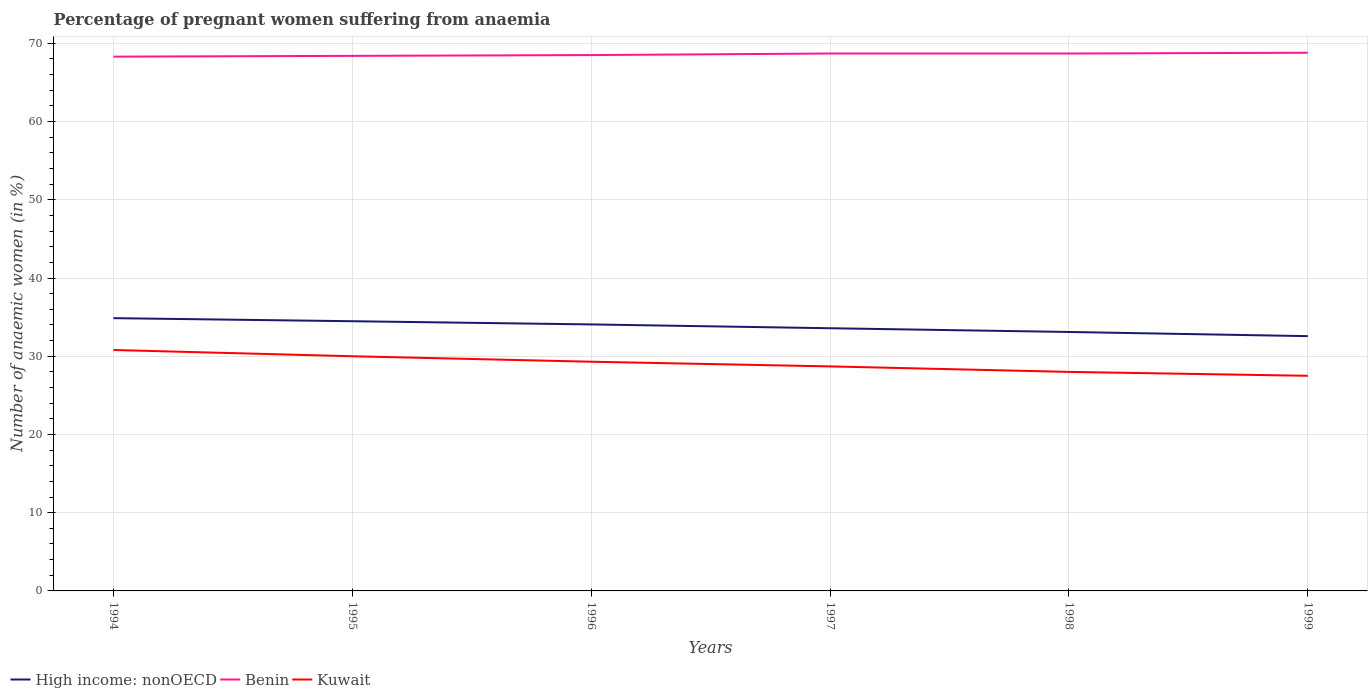How many different coloured lines are there?
Offer a very short reply. 3. What is the total number of anaemic women in Benin in the graph?
Make the answer very short. -0.3. What is the difference between the highest and the second highest number of anaemic women in Benin?
Make the answer very short. 0.5. Is the number of anaemic women in High income: nonOECD strictly greater than the number of anaemic women in Benin over the years?
Give a very brief answer. Yes. How many lines are there?
Make the answer very short. 3. How many years are there in the graph?
Keep it short and to the point. 6. Does the graph contain any zero values?
Offer a terse response. No. Does the graph contain grids?
Ensure brevity in your answer.  Yes. How many legend labels are there?
Provide a succinct answer. 3. How are the legend labels stacked?
Your response must be concise. Horizontal. What is the title of the graph?
Keep it short and to the point. Percentage of pregnant women suffering from anaemia. What is the label or title of the X-axis?
Your answer should be compact. Years. What is the label or title of the Y-axis?
Offer a terse response. Number of anaemic women (in %). What is the Number of anaemic women (in %) of High income: nonOECD in 1994?
Your response must be concise. 34.87. What is the Number of anaemic women (in %) in Benin in 1994?
Keep it short and to the point. 68.3. What is the Number of anaemic women (in %) in Kuwait in 1994?
Provide a succinct answer. 30.8. What is the Number of anaemic women (in %) in High income: nonOECD in 1995?
Keep it short and to the point. 34.48. What is the Number of anaemic women (in %) of Benin in 1995?
Provide a short and direct response. 68.4. What is the Number of anaemic women (in %) in Kuwait in 1995?
Your response must be concise. 30. What is the Number of anaemic women (in %) of High income: nonOECD in 1996?
Your response must be concise. 34.07. What is the Number of anaemic women (in %) of Benin in 1996?
Your answer should be very brief. 68.5. What is the Number of anaemic women (in %) of Kuwait in 1996?
Your response must be concise. 29.3. What is the Number of anaemic women (in %) in High income: nonOECD in 1997?
Give a very brief answer. 33.58. What is the Number of anaemic women (in %) of Benin in 1997?
Give a very brief answer. 68.7. What is the Number of anaemic women (in %) of Kuwait in 1997?
Offer a very short reply. 28.7. What is the Number of anaemic women (in %) in High income: nonOECD in 1998?
Offer a terse response. 33.1. What is the Number of anaemic women (in %) of Benin in 1998?
Provide a succinct answer. 68.7. What is the Number of anaemic women (in %) in High income: nonOECD in 1999?
Offer a very short reply. 32.57. What is the Number of anaemic women (in %) of Benin in 1999?
Your answer should be compact. 68.8. Across all years, what is the maximum Number of anaemic women (in %) of High income: nonOECD?
Offer a very short reply. 34.87. Across all years, what is the maximum Number of anaemic women (in %) of Benin?
Make the answer very short. 68.8. Across all years, what is the maximum Number of anaemic women (in %) in Kuwait?
Your answer should be very brief. 30.8. Across all years, what is the minimum Number of anaemic women (in %) in High income: nonOECD?
Ensure brevity in your answer.  32.57. Across all years, what is the minimum Number of anaemic women (in %) in Benin?
Your response must be concise. 68.3. Across all years, what is the minimum Number of anaemic women (in %) in Kuwait?
Give a very brief answer. 27.5. What is the total Number of anaemic women (in %) in High income: nonOECD in the graph?
Provide a short and direct response. 202.67. What is the total Number of anaemic women (in %) of Benin in the graph?
Offer a very short reply. 411.4. What is the total Number of anaemic women (in %) of Kuwait in the graph?
Offer a terse response. 174.3. What is the difference between the Number of anaemic women (in %) in High income: nonOECD in 1994 and that in 1995?
Make the answer very short. 0.39. What is the difference between the Number of anaemic women (in %) in Kuwait in 1994 and that in 1995?
Keep it short and to the point. 0.8. What is the difference between the Number of anaemic women (in %) in High income: nonOECD in 1994 and that in 1996?
Keep it short and to the point. 0.8. What is the difference between the Number of anaemic women (in %) of Benin in 1994 and that in 1996?
Your answer should be very brief. -0.2. What is the difference between the Number of anaemic women (in %) in High income: nonOECD in 1994 and that in 1997?
Offer a terse response. 1.29. What is the difference between the Number of anaemic women (in %) in Kuwait in 1994 and that in 1997?
Your response must be concise. 2.1. What is the difference between the Number of anaemic women (in %) of High income: nonOECD in 1994 and that in 1998?
Give a very brief answer. 1.76. What is the difference between the Number of anaemic women (in %) in Benin in 1994 and that in 1998?
Make the answer very short. -0.4. What is the difference between the Number of anaemic women (in %) of Kuwait in 1994 and that in 1998?
Offer a terse response. 2.8. What is the difference between the Number of anaemic women (in %) of High income: nonOECD in 1994 and that in 1999?
Offer a very short reply. 2.3. What is the difference between the Number of anaemic women (in %) in High income: nonOECD in 1995 and that in 1996?
Ensure brevity in your answer.  0.41. What is the difference between the Number of anaemic women (in %) in Kuwait in 1995 and that in 1996?
Keep it short and to the point. 0.7. What is the difference between the Number of anaemic women (in %) in High income: nonOECD in 1995 and that in 1997?
Ensure brevity in your answer.  0.9. What is the difference between the Number of anaemic women (in %) of Benin in 1995 and that in 1997?
Your response must be concise. -0.3. What is the difference between the Number of anaemic women (in %) of Kuwait in 1995 and that in 1997?
Give a very brief answer. 1.3. What is the difference between the Number of anaemic women (in %) of High income: nonOECD in 1995 and that in 1998?
Offer a terse response. 1.37. What is the difference between the Number of anaemic women (in %) in Kuwait in 1995 and that in 1998?
Make the answer very short. 2. What is the difference between the Number of anaemic women (in %) in High income: nonOECD in 1995 and that in 1999?
Offer a terse response. 1.91. What is the difference between the Number of anaemic women (in %) of Benin in 1995 and that in 1999?
Make the answer very short. -0.4. What is the difference between the Number of anaemic women (in %) in High income: nonOECD in 1996 and that in 1997?
Provide a short and direct response. 0.49. What is the difference between the Number of anaemic women (in %) in Benin in 1996 and that in 1997?
Your response must be concise. -0.2. What is the difference between the Number of anaemic women (in %) in High income: nonOECD in 1996 and that in 1998?
Provide a succinct answer. 0.96. What is the difference between the Number of anaemic women (in %) of High income: nonOECD in 1996 and that in 1999?
Your answer should be very brief. 1.5. What is the difference between the Number of anaemic women (in %) of Kuwait in 1996 and that in 1999?
Offer a very short reply. 1.8. What is the difference between the Number of anaemic women (in %) in High income: nonOECD in 1997 and that in 1998?
Offer a terse response. 0.48. What is the difference between the Number of anaemic women (in %) in Kuwait in 1997 and that in 1998?
Provide a short and direct response. 0.7. What is the difference between the Number of anaemic women (in %) of High income: nonOECD in 1997 and that in 1999?
Give a very brief answer. 1.01. What is the difference between the Number of anaemic women (in %) in Benin in 1997 and that in 1999?
Make the answer very short. -0.1. What is the difference between the Number of anaemic women (in %) of Kuwait in 1997 and that in 1999?
Your answer should be compact. 1.2. What is the difference between the Number of anaemic women (in %) of High income: nonOECD in 1998 and that in 1999?
Keep it short and to the point. 0.53. What is the difference between the Number of anaemic women (in %) of Benin in 1998 and that in 1999?
Offer a terse response. -0.1. What is the difference between the Number of anaemic women (in %) of Kuwait in 1998 and that in 1999?
Keep it short and to the point. 0.5. What is the difference between the Number of anaemic women (in %) of High income: nonOECD in 1994 and the Number of anaemic women (in %) of Benin in 1995?
Keep it short and to the point. -33.53. What is the difference between the Number of anaemic women (in %) of High income: nonOECD in 1994 and the Number of anaemic women (in %) of Kuwait in 1995?
Give a very brief answer. 4.87. What is the difference between the Number of anaemic women (in %) in Benin in 1994 and the Number of anaemic women (in %) in Kuwait in 1995?
Offer a terse response. 38.3. What is the difference between the Number of anaemic women (in %) in High income: nonOECD in 1994 and the Number of anaemic women (in %) in Benin in 1996?
Give a very brief answer. -33.63. What is the difference between the Number of anaemic women (in %) of High income: nonOECD in 1994 and the Number of anaemic women (in %) of Kuwait in 1996?
Provide a succinct answer. 5.57. What is the difference between the Number of anaemic women (in %) of High income: nonOECD in 1994 and the Number of anaemic women (in %) of Benin in 1997?
Offer a very short reply. -33.83. What is the difference between the Number of anaemic women (in %) of High income: nonOECD in 1994 and the Number of anaemic women (in %) of Kuwait in 1997?
Give a very brief answer. 6.17. What is the difference between the Number of anaemic women (in %) of Benin in 1994 and the Number of anaemic women (in %) of Kuwait in 1997?
Offer a very short reply. 39.6. What is the difference between the Number of anaemic women (in %) of High income: nonOECD in 1994 and the Number of anaemic women (in %) of Benin in 1998?
Offer a terse response. -33.83. What is the difference between the Number of anaemic women (in %) of High income: nonOECD in 1994 and the Number of anaemic women (in %) of Kuwait in 1998?
Ensure brevity in your answer.  6.87. What is the difference between the Number of anaemic women (in %) in Benin in 1994 and the Number of anaemic women (in %) in Kuwait in 1998?
Your answer should be very brief. 40.3. What is the difference between the Number of anaemic women (in %) of High income: nonOECD in 1994 and the Number of anaemic women (in %) of Benin in 1999?
Your answer should be very brief. -33.93. What is the difference between the Number of anaemic women (in %) in High income: nonOECD in 1994 and the Number of anaemic women (in %) in Kuwait in 1999?
Your answer should be compact. 7.37. What is the difference between the Number of anaemic women (in %) of Benin in 1994 and the Number of anaemic women (in %) of Kuwait in 1999?
Make the answer very short. 40.8. What is the difference between the Number of anaemic women (in %) of High income: nonOECD in 1995 and the Number of anaemic women (in %) of Benin in 1996?
Make the answer very short. -34.02. What is the difference between the Number of anaemic women (in %) of High income: nonOECD in 1995 and the Number of anaemic women (in %) of Kuwait in 1996?
Your answer should be very brief. 5.18. What is the difference between the Number of anaemic women (in %) in Benin in 1995 and the Number of anaemic women (in %) in Kuwait in 1996?
Ensure brevity in your answer.  39.1. What is the difference between the Number of anaemic women (in %) of High income: nonOECD in 1995 and the Number of anaemic women (in %) of Benin in 1997?
Keep it short and to the point. -34.22. What is the difference between the Number of anaemic women (in %) in High income: nonOECD in 1995 and the Number of anaemic women (in %) in Kuwait in 1997?
Provide a succinct answer. 5.78. What is the difference between the Number of anaemic women (in %) of Benin in 1995 and the Number of anaemic women (in %) of Kuwait in 1997?
Make the answer very short. 39.7. What is the difference between the Number of anaemic women (in %) of High income: nonOECD in 1995 and the Number of anaemic women (in %) of Benin in 1998?
Make the answer very short. -34.22. What is the difference between the Number of anaemic women (in %) in High income: nonOECD in 1995 and the Number of anaemic women (in %) in Kuwait in 1998?
Your response must be concise. 6.48. What is the difference between the Number of anaemic women (in %) in Benin in 1995 and the Number of anaemic women (in %) in Kuwait in 1998?
Offer a very short reply. 40.4. What is the difference between the Number of anaemic women (in %) in High income: nonOECD in 1995 and the Number of anaemic women (in %) in Benin in 1999?
Your answer should be compact. -34.32. What is the difference between the Number of anaemic women (in %) in High income: nonOECD in 1995 and the Number of anaemic women (in %) in Kuwait in 1999?
Your answer should be compact. 6.98. What is the difference between the Number of anaemic women (in %) in Benin in 1995 and the Number of anaemic women (in %) in Kuwait in 1999?
Ensure brevity in your answer.  40.9. What is the difference between the Number of anaemic women (in %) of High income: nonOECD in 1996 and the Number of anaemic women (in %) of Benin in 1997?
Your answer should be very brief. -34.63. What is the difference between the Number of anaemic women (in %) in High income: nonOECD in 1996 and the Number of anaemic women (in %) in Kuwait in 1997?
Keep it short and to the point. 5.37. What is the difference between the Number of anaemic women (in %) in Benin in 1996 and the Number of anaemic women (in %) in Kuwait in 1997?
Offer a terse response. 39.8. What is the difference between the Number of anaemic women (in %) of High income: nonOECD in 1996 and the Number of anaemic women (in %) of Benin in 1998?
Provide a short and direct response. -34.63. What is the difference between the Number of anaemic women (in %) of High income: nonOECD in 1996 and the Number of anaemic women (in %) of Kuwait in 1998?
Provide a succinct answer. 6.07. What is the difference between the Number of anaemic women (in %) in Benin in 1996 and the Number of anaemic women (in %) in Kuwait in 1998?
Ensure brevity in your answer.  40.5. What is the difference between the Number of anaemic women (in %) of High income: nonOECD in 1996 and the Number of anaemic women (in %) of Benin in 1999?
Your answer should be very brief. -34.73. What is the difference between the Number of anaemic women (in %) of High income: nonOECD in 1996 and the Number of anaemic women (in %) of Kuwait in 1999?
Offer a terse response. 6.57. What is the difference between the Number of anaemic women (in %) in Benin in 1996 and the Number of anaemic women (in %) in Kuwait in 1999?
Keep it short and to the point. 41. What is the difference between the Number of anaemic women (in %) of High income: nonOECD in 1997 and the Number of anaemic women (in %) of Benin in 1998?
Offer a very short reply. -35.12. What is the difference between the Number of anaemic women (in %) in High income: nonOECD in 1997 and the Number of anaemic women (in %) in Kuwait in 1998?
Your answer should be compact. 5.58. What is the difference between the Number of anaemic women (in %) of Benin in 1997 and the Number of anaemic women (in %) of Kuwait in 1998?
Provide a succinct answer. 40.7. What is the difference between the Number of anaemic women (in %) in High income: nonOECD in 1997 and the Number of anaemic women (in %) in Benin in 1999?
Your answer should be compact. -35.22. What is the difference between the Number of anaemic women (in %) in High income: nonOECD in 1997 and the Number of anaemic women (in %) in Kuwait in 1999?
Offer a terse response. 6.08. What is the difference between the Number of anaemic women (in %) in Benin in 1997 and the Number of anaemic women (in %) in Kuwait in 1999?
Your answer should be compact. 41.2. What is the difference between the Number of anaemic women (in %) of High income: nonOECD in 1998 and the Number of anaemic women (in %) of Benin in 1999?
Your answer should be very brief. -35.7. What is the difference between the Number of anaemic women (in %) in High income: nonOECD in 1998 and the Number of anaemic women (in %) in Kuwait in 1999?
Offer a terse response. 5.6. What is the difference between the Number of anaemic women (in %) of Benin in 1998 and the Number of anaemic women (in %) of Kuwait in 1999?
Your answer should be compact. 41.2. What is the average Number of anaemic women (in %) of High income: nonOECD per year?
Your response must be concise. 33.78. What is the average Number of anaemic women (in %) in Benin per year?
Provide a succinct answer. 68.57. What is the average Number of anaemic women (in %) in Kuwait per year?
Your answer should be compact. 29.05. In the year 1994, what is the difference between the Number of anaemic women (in %) in High income: nonOECD and Number of anaemic women (in %) in Benin?
Offer a terse response. -33.43. In the year 1994, what is the difference between the Number of anaemic women (in %) in High income: nonOECD and Number of anaemic women (in %) in Kuwait?
Provide a short and direct response. 4.07. In the year 1994, what is the difference between the Number of anaemic women (in %) in Benin and Number of anaemic women (in %) in Kuwait?
Your answer should be very brief. 37.5. In the year 1995, what is the difference between the Number of anaemic women (in %) in High income: nonOECD and Number of anaemic women (in %) in Benin?
Provide a short and direct response. -33.92. In the year 1995, what is the difference between the Number of anaemic women (in %) of High income: nonOECD and Number of anaemic women (in %) of Kuwait?
Ensure brevity in your answer.  4.48. In the year 1995, what is the difference between the Number of anaemic women (in %) in Benin and Number of anaemic women (in %) in Kuwait?
Make the answer very short. 38.4. In the year 1996, what is the difference between the Number of anaemic women (in %) of High income: nonOECD and Number of anaemic women (in %) of Benin?
Offer a terse response. -34.43. In the year 1996, what is the difference between the Number of anaemic women (in %) of High income: nonOECD and Number of anaemic women (in %) of Kuwait?
Your answer should be very brief. 4.77. In the year 1996, what is the difference between the Number of anaemic women (in %) of Benin and Number of anaemic women (in %) of Kuwait?
Ensure brevity in your answer.  39.2. In the year 1997, what is the difference between the Number of anaemic women (in %) in High income: nonOECD and Number of anaemic women (in %) in Benin?
Ensure brevity in your answer.  -35.12. In the year 1997, what is the difference between the Number of anaemic women (in %) in High income: nonOECD and Number of anaemic women (in %) in Kuwait?
Ensure brevity in your answer.  4.88. In the year 1997, what is the difference between the Number of anaemic women (in %) of Benin and Number of anaemic women (in %) of Kuwait?
Your answer should be compact. 40. In the year 1998, what is the difference between the Number of anaemic women (in %) in High income: nonOECD and Number of anaemic women (in %) in Benin?
Ensure brevity in your answer.  -35.6. In the year 1998, what is the difference between the Number of anaemic women (in %) in High income: nonOECD and Number of anaemic women (in %) in Kuwait?
Offer a terse response. 5.1. In the year 1998, what is the difference between the Number of anaemic women (in %) in Benin and Number of anaemic women (in %) in Kuwait?
Your answer should be very brief. 40.7. In the year 1999, what is the difference between the Number of anaemic women (in %) of High income: nonOECD and Number of anaemic women (in %) of Benin?
Offer a very short reply. -36.23. In the year 1999, what is the difference between the Number of anaemic women (in %) in High income: nonOECD and Number of anaemic women (in %) in Kuwait?
Offer a terse response. 5.07. In the year 1999, what is the difference between the Number of anaemic women (in %) of Benin and Number of anaemic women (in %) of Kuwait?
Your answer should be very brief. 41.3. What is the ratio of the Number of anaemic women (in %) of High income: nonOECD in 1994 to that in 1995?
Your answer should be very brief. 1.01. What is the ratio of the Number of anaemic women (in %) of Benin in 1994 to that in 1995?
Offer a terse response. 1. What is the ratio of the Number of anaemic women (in %) in Kuwait in 1994 to that in 1995?
Offer a terse response. 1.03. What is the ratio of the Number of anaemic women (in %) of High income: nonOECD in 1994 to that in 1996?
Ensure brevity in your answer.  1.02. What is the ratio of the Number of anaemic women (in %) in Kuwait in 1994 to that in 1996?
Make the answer very short. 1.05. What is the ratio of the Number of anaemic women (in %) of High income: nonOECD in 1994 to that in 1997?
Offer a very short reply. 1.04. What is the ratio of the Number of anaemic women (in %) in Kuwait in 1994 to that in 1997?
Keep it short and to the point. 1.07. What is the ratio of the Number of anaemic women (in %) of High income: nonOECD in 1994 to that in 1998?
Keep it short and to the point. 1.05. What is the ratio of the Number of anaemic women (in %) in Benin in 1994 to that in 1998?
Your answer should be compact. 0.99. What is the ratio of the Number of anaemic women (in %) of Kuwait in 1994 to that in 1998?
Make the answer very short. 1.1. What is the ratio of the Number of anaemic women (in %) of High income: nonOECD in 1994 to that in 1999?
Offer a very short reply. 1.07. What is the ratio of the Number of anaemic women (in %) in Benin in 1994 to that in 1999?
Keep it short and to the point. 0.99. What is the ratio of the Number of anaemic women (in %) of Kuwait in 1994 to that in 1999?
Provide a succinct answer. 1.12. What is the ratio of the Number of anaemic women (in %) of High income: nonOECD in 1995 to that in 1996?
Provide a short and direct response. 1.01. What is the ratio of the Number of anaemic women (in %) of Benin in 1995 to that in 1996?
Make the answer very short. 1. What is the ratio of the Number of anaemic women (in %) in Kuwait in 1995 to that in 1996?
Your answer should be compact. 1.02. What is the ratio of the Number of anaemic women (in %) in High income: nonOECD in 1995 to that in 1997?
Your answer should be compact. 1.03. What is the ratio of the Number of anaemic women (in %) of Benin in 1995 to that in 1997?
Make the answer very short. 1. What is the ratio of the Number of anaemic women (in %) of Kuwait in 1995 to that in 1997?
Keep it short and to the point. 1.05. What is the ratio of the Number of anaemic women (in %) in High income: nonOECD in 1995 to that in 1998?
Your answer should be very brief. 1.04. What is the ratio of the Number of anaemic women (in %) in Kuwait in 1995 to that in 1998?
Ensure brevity in your answer.  1.07. What is the ratio of the Number of anaemic women (in %) of High income: nonOECD in 1995 to that in 1999?
Offer a terse response. 1.06. What is the ratio of the Number of anaemic women (in %) of High income: nonOECD in 1996 to that in 1997?
Give a very brief answer. 1.01. What is the ratio of the Number of anaemic women (in %) of Benin in 1996 to that in 1997?
Your response must be concise. 1. What is the ratio of the Number of anaemic women (in %) in Kuwait in 1996 to that in 1997?
Offer a very short reply. 1.02. What is the ratio of the Number of anaemic women (in %) of High income: nonOECD in 1996 to that in 1998?
Offer a very short reply. 1.03. What is the ratio of the Number of anaemic women (in %) in Benin in 1996 to that in 1998?
Provide a short and direct response. 1. What is the ratio of the Number of anaemic women (in %) of Kuwait in 1996 to that in 1998?
Ensure brevity in your answer.  1.05. What is the ratio of the Number of anaemic women (in %) in High income: nonOECD in 1996 to that in 1999?
Offer a terse response. 1.05. What is the ratio of the Number of anaemic women (in %) of Benin in 1996 to that in 1999?
Keep it short and to the point. 1. What is the ratio of the Number of anaemic women (in %) of Kuwait in 1996 to that in 1999?
Make the answer very short. 1.07. What is the ratio of the Number of anaemic women (in %) of High income: nonOECD in 1997 to that in 1998?
Offer a very short reply. 1.01. What is the ratio of the Number of anaemic women (in %) of High income: nonOECD in 1997 to that in 1999?
Make the answer very short. 1.03. What is the ratio of the Number of anaemic women (in %) of Kuwait in 1997 to that in 1999?
Offer a very short reply. 1.04. What is the ratio of the Number of anaemic women (in %) of High income: nonOECD in 1998 to that in 1999?
Make the answer very short. 1.02. What is the ratio of the Number of anaemic women (in %) in Kuwait in 1998 to that in 1999?
Your response must be concise. 1.02. What is the difference between the highest and the second highest Number of anaemic women (in %) of High income: nonOECD?
Your response must be concise. 0.39. What is the difference between the highest and the lowest Number of anaemic women (in %) of High income: nonOECD?
Provide a succinct answer. 2.3. What is the difference between the highest and the lowest Number of anaemic women (in %) in Benin?
Provide a succinct answer. 0.5. What is the difference between the highest and the lowest Number of anaemic women (in %) of Kuwait?
Give a very brief answer. 3.3. 